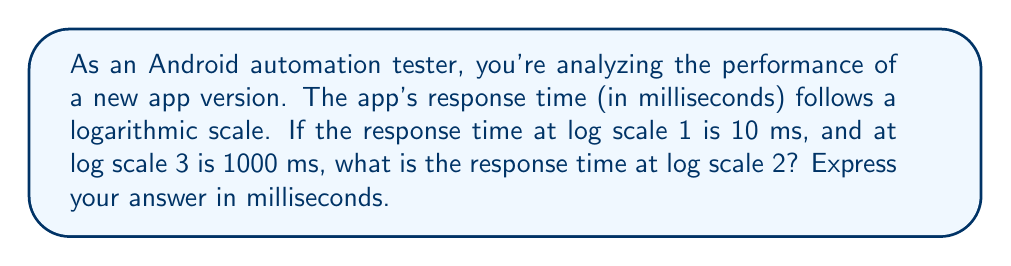What is the answer to this math problem? Let's approach this step-by-step:

1) We're dealing with a logarithmic scale, so we can use the exponential function to model this relationship. Let's say the response time $y$ is related to the log scale $x$ by the equation:

   $$y = a \cdot b^x$$

   where $a$ and $b$ are constants we need to determine.

2) We have two known points:
   At $x = 1$, $y = 10$
   At $x = 3$, $y = 1000$

3) Let's substitute these into our equation:
   
   $$10 = a \cdot b^1$$
   $$1000 = a \cdot b^3$$

4) Dividing the second equation by the first:

   $$\frac{1000}{10} = \frac{a \cdot b^3}{a \cdot b^1}$$

   $$100 = b^2$$

5) Solving for $b$:

   $$b = \sqrt{100} = 10$$

6) Now we can find $a$ using either of our original equations. Let's use the first one:

   $$10 = a \cdot 10^1$$
   $$a = 1$$

7) So our equation is:

   $$y = 1 \cdot 10^x$$

   or simply:

   $$y = 10^x$$

8) To find the response time at log scale 2, we substitute $x = 2$:

   $$y = 10^2 = 100$$

Therefore, at log scale 2, the response time is 100 ms.
Answer: 100 ms 